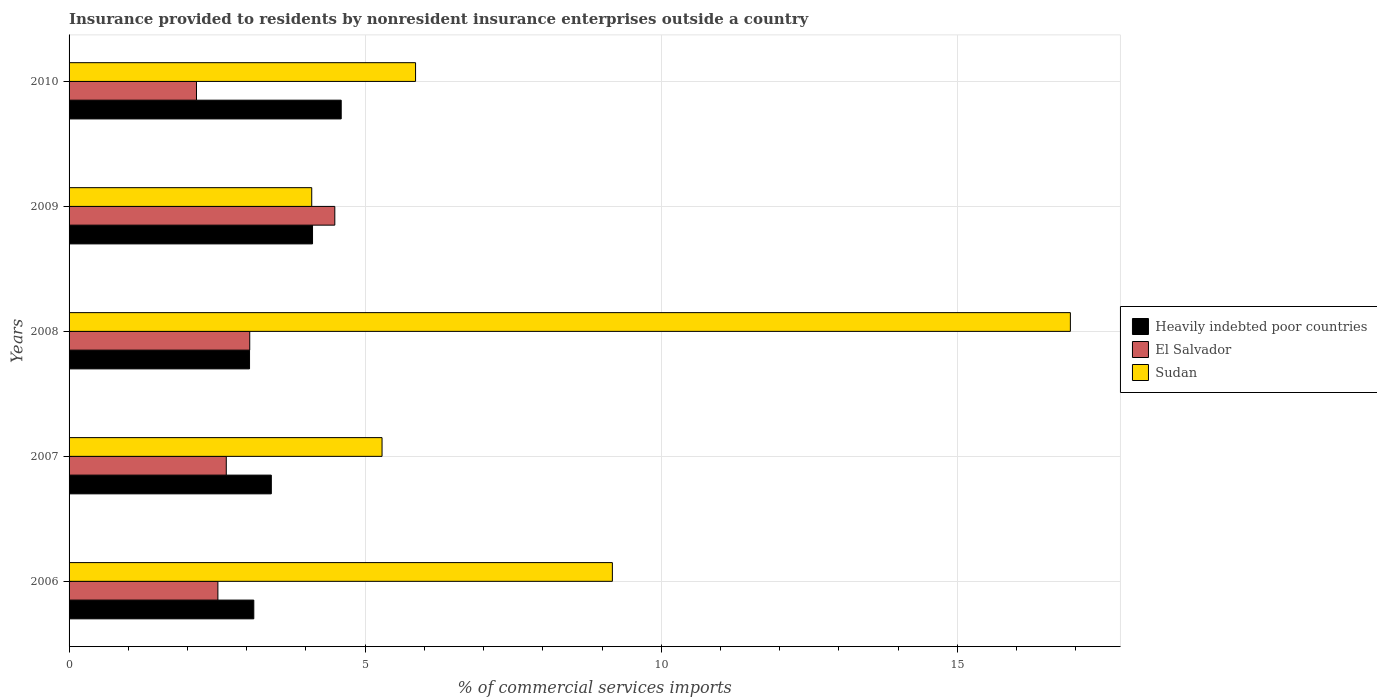Are the number of bars on each tick of the Y-axis equal?
Provide a short and direct response. Yes. How many bars are there on the 1st tick from the bottom?
Your response must be concise. 3. What is the Insurance provided to residents in Heavily indebted poor countries in 2006?
Keep it short and to the point. 3.12. Across all years, what is the maximum Insurance provided to residents in Sudan?
Offer a terse response. 16.91. Across all years, what is the minimum Insurance provided to residents in Heavily indebted poor countries?
Make the answer very short. 3.05. In which year was the Insurance provided to residents in El Salvador minimum?
Your answer should be very brief. 2010. What is the total Insurance provided to residents in Sudan in the graph?
Your answer should be compact. 41.32. What is the difference between the Insurance provided to residents in El Salvador in 2006 and that in 2010?
Give a very brief answer. 0.36. What is the difference between the Insurance provided to residents in Heavily indebted poor countries in 2010 and the Insurance provided to residents in Sudan in 2008?
Keep it short and to the point. -12.31. What is the average Insurance provided to residents in El Salvador per year?
Offer a terse response. 2.97. In the year 2006, what is the difference between the Insurance provided to residents in Heavily indebted poor countries and Insurance provided to residents in El Salvador?
Provide a short and direct response. 0.61. What is the ratio of the Insurance provided to residents in Heavily indebted poor countries in 2009 to that in 2010?
Make the answer very short. 0.89. Is the Insurance provided to residents in Heavily indebted poor countries in 2006 less than that in 2009?
Ensure brevity in your answer.  Yes. What is the difference between the highest and the second highest Insurance provided to residents in El Salvador?
Offer a terse response. 1.44. What is the difference between the highest and the lowest Insurance provided to residents in El Salvador?
Offer a terse response. 2.34. What does the 2nd bar from the top in 2010 represents?
Offer a very short reply. El Salvador. What does the 1st bar from the bottom in 2008 represents?
Make the answer very short. Heavily indebted poor countries. Are all the bars in the graph horizontal?
Keep it short and to the point. Yes. What is the difference between two consecutive major ticks on the X-axis?
Your answer should be very brief. 5. Does the graph contain grids?
Provide a short and direct response. Yes. Where does the legend appear in the graph?
Give a very brief answer. Center right. What is the title of the graph?
Offer a terse response. Insurance provided to residents by nonresident insurance enterprises outside a country. Does "Iran" appear as one of the legend labels in the graph?
Ensure brevity in your answer.  No. What is the label or title of the X-axis?
Your answer should be very brief. % of commercial services imports. What is the label or title of the Y-axis?
Keep it short and to the point. Years. What is the % of commercial services imports of Heavily indebted poor countries in 2006?
Provide a succinct answer. 3.12. What is the % of commercial services imports of El Salvador in 2006?
Your answer should be very brief. 2.51. What is the % of commercial services imports of Sudan in 2006?
Your response must be concise. 9.17. What is the % of commercial services imports of Heavily indebted poor countries in 2007?
Make the answer very short. 3.42. What is the % of commercial services imports in El Salvador in 2007?
Keep it short and to the point. 2.65. What is the % of commercial services imports of Sudan in 2007?
Provide a succinct answer. 5.29. What is the % of commercial services imports in Heavily indebted poor countries in 2008?
Your answer should be compact. 3.05. What is the % of commercial services imports of El Salvador in 2008?
Keep it short and to the point. 3.05. What is the % of commercial services imports in Sudan in 2008?
Provide a succinct answer. 16.91. What is the % of commercial services imports of Heavily indebted poor countries in 2009?
Keep it short and to the point. 4.11. What is the % of commercial services imports in El Salvador in 2009?
Offer a very short reply. 4.49. What is the % of commercial services imports of Sudan in 2009?
Offer a very short reply. 4.1. What is the % of commercial services imports of Heavily indebted poor countries in 2010?
Offer a terse response. 4.6. What is the % of commercial services imports of El Salvador in 2010?
Give a very brief answer. 2.15. What is the % of commercial services imports of Sudan in 2010?
Provide a succinct answer. 5.85. Across all years, what is the maximum % of commercial services imports of Heavily indebted poor countries?
Give a very brief answer. 4.6. Across all years, what is the maximum % of commercial services imports in El Salvador?
Provide a succinct answer. 4.49. Across all years, what is the maximum % of commercial services imports in Sudan?
Make the answer very short. 16.91. Across all years, what is the minimum % of commercial services imports of Heavily indebted poor countries?
Your answer should be compact. 3.05. Across all years, what is the minimum % of commercial services imports of El Salvador?
Your answer should be compact. 2.15. Across all years, what is the minimum % of commercial services imports in Sudan?
Ensure brevity in your answer.  4.1. What is the total % of commercial services imports in Heavily indebted poor countries in the graph?
Offer a terse response. 18.29. What is the total % of commercial services imports of El Salvador in the graph?
Provide a succinct answer. 14.86. What is the total % of commercial services imports of Sudan in the graph?
Give a very brief answer. 41.32. What is the difference between the % of commercial services imports in Heavily indebted poor countries in 2006 and that in 2007?
Provide a succinct answer. -0.3. What is the difference between the % of commercial services imports of El Salvador in 2006 and that in 2007?
Your response must be concise. -0.14. What is the difference between the % of commercial services imports in Sudan in 2006 and that in 2007?
Provide a succinct answer. 3.89. What is the difference between the % of commercial services imports of Heavily indebted poor countries in 2006 and that in 2008?
Your response must be concise. 0.07. What is the difference between the % of commercial services imports in El Salvador in 2006 and that in 2008?
Your answer should be compact. -0.54. What is the difference between the % of commercial services imports in Sudan in 2006 and that in 2008?
Give a very brief answer. -7.73. What is the difference between the % of commercial services imports of Heavily indebted poor countries in 2006 and that in 2009?
Ensure brevity in your answer.  -0.99. What is the difference between the % of commercial services imports in El Salvador in 2006 and that in 2009?
Ensure brevity in your answer.  -1.97. What is the difference between the % of commercial services imports in Sudan in 2006 and that in 2009?
Your answer should be compact. 5.08. What is the difference between the % of commercial services imports of Heavily indebted poor countries in 2006 and that in 2010?
Your answer should be compact. -1.48. What is the difference between the % of commercial services imports of El Salvador in 2006 and that in 2010?
Provide a succinct answer. 0.36. What is the difference between the % of commercial services imports in Sudan in 2006 and that in 2010?
Your answer should be very brief. 3.32. What is the difference between the % of commercial services imports in Heavily indebted poor countries in 2007 and that in 2008?
Give a very brief answer. 0.37. What is the difference between the % of commercial services imports in El Salvador in 2007 and that in 2008?
Ensure brevity in your answer.  -0.4. What is the difference between the % of commercial services imports of Sudan in 2007 and that in 2008?
Offer a very short reply. -11.62. What is the difference between the % of commercial services imports of Heavily indebted poor countries in 2007 and that in 2009?
Your answer should be very brief. -0.7. What is the difference between the % of commercial services imports of El Salvador in 2007 and that in 2009?
Provide a succinct answer. -1.83. What is the difference between the % of commercial services imports of Sudan in 2007 and that in 2009?
Give a very brief answer. 1.19. What is the difference between the % of commercial services imports in Heavily indebted poor countries in 2007 and that in 2010?
Offer a terse response. -1.18. What is the difference between the % of commercial services imports of El Salvador in 2007 and that in 2010?
Give a very brief answer. 0.5. What is the difference between the % of commercial services imports in Sudan in 2007 and that in 2010?
Give a very brief answer. -0.57. What is the difference between the % of commercial services imports in Heavily indebted poor countries in 2008 and that in 2009?
Your response must be concise. -1.06. What is the difference between the % of commercial services imports in El Salvador in 2008 and that in 2009?
Offer a very short reply. -1.44. What is the difference between the % of commercial services imports in Sudan in 2008 and that in 2009?
Provide a succinct answer. 12.81. What is the difference between the % of commercial services imports in Heavily indebted poor countries in 2008 and that in 2010?
Your answer should be very brief. -1.55. What is the difference between the % of commercial services imports of El Salvador in 2008 and that in 2010?
Keep it short and to the point. 0.9. What is the difference between the % of commercial services imports in Sudan in 2008 and that in 2010?
Your answer should be compact. 11.06. What is the difference between the % of commercial services imports of Heavily indebted poor countries in 2009 and that in 2010?
Make the answer very short. -0.48. What is the difference between the % of commercial services imports of El Salvador in 2009 and that in 2010?
Your response must be concise. 2.34. What is the difference between the % of commercial services imports of Sudan in 2009 and that in 2010?
Offer a very short reply. -1.75. What is the difference between the % of commercial services imports in Heavily indebted poor countries in 2006 and the % of commercial services imports in El Salvador in 2007?
Provide a short and direct response. 0.46. What is the difference between the % of commercial services imports in Heavily indebted poor countries in 2006 and the % of commercial services imports in Sudan in 2007?
Keep it short and to the point. -2.17. What is the difference between the % of commercial services imports in El Salvador in 2006 and the % of commercial services imports in Sudan in 2007?
Your answer should be compact. -2.77. What is the difference between the % of commercial services imports of Heavily indebted poor countries in 2006 and the % of commercial services imports of El Salvador in 2008?
Provide a short and direct response. 0.07. What is the difference between the % of commercial services imports of Heavily indebted poor countries in 2006 and the % of commercial services imports of Sudan in 2008?
Your answer should be compact. -13.79. What is the difference between the % of commercial services imports of El Salvador in 2006 and the % of commercial services imports of Sudan in 2008?
Provide a short and direct response. -14.4. What is the difference between the % of commercial services imports of Heavily indebted poor countries in 2006 and the % of commercial services imports of El Salvador in 2009?
Your answer should be very brief. -1.37. What is the difference between the % of commercial services imports of Heavily indebted poor countries in 2006 and the % of commercial services imports of Sudan in 2009?
Make the answer very short. -0.98. What is the difference between the % of commercial services imports in El Salvador in 2006 and the % of commercial services imports in Sudan in 2009?
Give a very brief answer. -1.58. What is the difference between the % of commercial services imports in Heavily indebted poor countries in 2006 and the % of commercial services imports in El Salvador in 2010?
Provide a succinct answer. 0.97. What is the difference between the % of commercial services imports in Heavily indebted poor countries in 2006 and the % of commercial services imports in Sudan in 2010?
Offer a very short reply. -2.73. What is the difference between the % of commercial services imports in El Salvador in 2006 and the % of commercial services imports in Sudan in 2010?
Make the answer very short. -3.34. What is the difference between the % of commercial services imports of Heavily indebted poor countries in 2007 and the % of commercial services imports of El Salvador in 2008?
Offer a very short reply. 0.36. What is the difference between the % of commercial services imports of Heavily indebted poor countries in 2007 and the % of commercial services imports of Sudan in 2008?
Ensure brevity in your answer.  -13.49. What is the difference between the % of commercial services imports of El Salvador in 2007 and the % of commercial services imports of Sudan in 2008?
Your answer should be very brief. -14.25. What is the difference between the % of commercial services imports in Heavily indebted poor countries in 2007 and the % of commercial services imports in El Salvador in 2009?
Offer a very short reply. -1.07. What is the difference between the % of commercial services imports of Heavily indebted poor countries in 2007 and the % of commercial services imports of Sudan in 2009?
Keep it short and to the point. -0.68. What is the difference between the % of commercial services imports of El Salvador in 2007 and the % of commercial services imports of Sudan in 2009?
Offer a terse response. -1.44. What is the difference between the % of commercial services imports in Heavily indebted poor countries in 2007 and the % of commercial services imports in El Salvador in 2010?
Offer a very short reply. 1.26. What is the difference between the % of commercial services imports in Heavily indebted poor countries in 2007 and the % of commercial services imports in Sudan in 2010?
Provide a succinct answer. -2.44. What is the difference between the % of commercial services imports in El Salvador in 2007 and the % of commercial services imports in Sudan in 2010?
Keep it short and to the point. -3.2. What is the difference between the % of commercial services imports of Heavily indebted poor countries in 2008 and the % of commercial services imports of El Salvador in 2009?
Offer a very short reply. -1.44. What is the difference between the % of commercial services imports of Heavily indebted poor countries in 2008 and the % of commercial services imports of Sudan in 2009?
Your answer should be compact. -1.05. What is the difference between the % of commercial services imports of El Salvador in 2008 and the % of commercial services imports of Sudan in 2009?
Offer a terse response. -1.05. What is the difference between the % of commercial services imports of Heavily indebted poor countries in 2008 and the % of commercial services imports of El Salvador in 2010?
Keep it short and to the point. 0.9. What is the difference between the % of commercial services imports of Heavily indebted poor countries in 2008 and the % of commercial services imports of Sudan in 2010?
Offer a terse response. -2.8. What is the difference between the % of commercial services imports in El Salvador in 2008 and the % of commercial services imports in Sudan in 2010?
Ensure brevity in your answer.  -2.8. What is the difference between the % of commercial services imports of Heavily indebted poor countries in 2009 and the % of commercial services imports of El Salvador in 2010?
Offer a very short reply. 1.96. What is the difference between the % of commercial services imports in Heavily indebted poor countries in 2009 and the % of commercial services imports in Sudan in 2010?
Give a very brief answer. -1.74. What is the difference between the % of commercial services imports in El Salvador in 2009 and the % of commercial services imports in Sudan in 2010?
Provide a short and direct response. -1.36. What is the average % of commercial services imports in Heavily indebted poor countries per year?
Provide a succinct answer. 3.66. What is the average % of commercial services imports in El Salvador per year?
Make the answer very short. 2.97. What is the average % of commercial services imports of Sudan per year?
Ensure brevity in your answer.  8.26. In the year 2006, what is the difference between the % of commercial services imports of Heavily indebted poor countries and % of commercial services imports of El Salvador?
Your response must be concise. 0.61. In the year 2006, what is the difference between the % of commercial services imports of Heavily indebted poor countries and % of commercial services imports of Sudan?
Your response must be concise. -6.06. In the year 2006, what is the difference between the % of commercial services imports of El Salvador and % of commercial services imports of Sudan?
Your answer should be compact. -6.66. In the year 2007, what is the difference between the % of commercial services imports of Heavily indebted poor countries and % of commercial services imports of El Salvador?
Give a very brief answer. 0.76. In the year 2007, what is the difference between the % of commercial services imports of Heavily indebted poor countries and % of commercial services imports of Sudan?
Give a very brief answer. -1.87. In the year 2007, what is the difference between the % of commercial services imports in El Salvador and % of commercial services imports in Sudan?
Your answer should be compact. -2.63. In the year 2008, what is the difference between the % of commercial services imports of Heavily indebted poor countries and % of commercial services imports of El Salvador?
Your response must be concise. -0. In the year 2008, what is the difference between the % of commercial services imports of Heavily indebted poor countries and % of commercial services imports of Sudan?
Your answer should be compact. -13.86. In the year 2008, what is the difference between the % of commercial services imports of El Salvador and % of commercial services imports of Sudan?
Your response must be concise. -13.86. In the year 2009, what is the difference between the % of commercial services imports of Heavily indebted poor countries and % of commercial services imports of El Salvador?
Make the answer very short. -0.38. In the year 2009, what is the difference between the % of commercial services imports in Heavily indebted poor countries and % of commercial services imports in Sudan?
Offer a very short reply. 0.01. In the year 2009, what is the difference between the % of commercial services imports of El Salvador and % of commercial services imports of Sudan?
Provide a short and direct response. 0.39. In the year 2010, what is the difference between the % of commercial services imports of Heavily indebted poor countries and % of commercial services imports of El Salvador?
Make the answer very short. 2.44. In the year 2010, what is the difference between the % of commercial services imports of Heavily indebted poor countries and % of commercial services imports of Sudan?
Your answer should be very brief. -1.26. In the year 2010, what is the difference between the % of commercial services imports in El Salvador and % of commercial services imports in Sudan?
Your answer should be very brief. -3.7. What is the ratio of the % of commercial services imports of Heavily indebted poor countries in 2006 to that in 2007?
Provide a short and direct response. 0.91. What is the ratio of the % of commercial services imports in El Salvador in 2006 to that in 2007?
Make the answer very short. 0.95. What is the ratio of the % of commercial services imports of Sudan in 2006 to that in 2007?
Provide a succinct answer. 1.74. What is the ratio of the % of commercial services imports of Heavily indebted poor countries in 2006 to that in 2008?
Your response must be concise. 1.02. What is the ratio of the % of commercial services imports of El Salvador in 2006 to that in 2008?
Offer a terse response. 0.82. What is the ratio of the % of commercial services imports in Sudan in 2006 to that in 2008?
Ensure brevity in your answer.  0.54. What is the ratio of the % of commercial services imports in Heavily indebted poor countries in 2006 to that in 2009?
Your response must be concise. 0.76. What is the ratio of the % of commercial services imports in El Salvador in 2006 to that in 2009?
Keep it short and to the point. 0.56. What is the ratio of the % of commercial services imports of Sudan in 2006 to that in 2009?
Your response must be concise. 2.24. What is the ratio of the % of commercial services imports of Heavily indebted poor countries in 2006 to that in 2010?
Give a very brief answer. 0.68. What is the ratio of the % of commercial services imports of El Salvador in 2006 to that in 2010?
Make the answer very short. 1.17. What is the ratio of the % of commercial services imports of Sudan in 2006 to that in 2010?
Your answer should be very brief. 1.57. What is the ratio of the % of commercial services imports of Heavily indebted poor countries in 2007 to that in 2008?
Ensure brevity in your answer.  1.12. What is the ratio of the % of commercial services imports in El Salvador in 2007 to that in 2008?
Ensure brevity in your answer.  0.87. What is the ratio of the % of commercial services imports in Sudan in 2007 to that in 2008?
Give a very brief answer. 0.31. What is the ratio of the % of commercial services imports in Heavily indebted poor countries in 2007 to that in 2009?
Provide a succinct answer. 0.83. What is the ratio of the % of commercial services imports in El Salvador in 2007 to that in 2009?
Offer a terse response. 0.59. What is the ratio of the % of commercial services imports of Sudan in 2007 to that in 2009?
Provide a short and direct response. 1.29. What is the ratio of the % of commercial services imports of Heavily indebted poor countries in 2007 to that in 2010?
Provide a succinct answer. 0.74. What is the ratio of the % of commercial services imports of El Salvador in 2007 to that in 2010?
Keep it short and to the point. 1.23. What is the ratio of the % of commercial services imports of Sudan in 2007 to that in 2010?
Give a very brief answer. 0.9. What is the ratio of the % of commercial services imports of Heavily indebted poor countries in 2008 to that in 2009?
Ensure brevity in your answer.  0.74. What is the ratio of the % of commercial services imports in El Salvador in 2008 to that in 2009?
Offer a very short reply. 0.68. What is the ratio of the % of commercial services imports in Sudan in 2008 to that in 2009?
Provide a short and direct response. 4.13. What is the ratio of the % of commercial services imports of Heavily indebted poor countries in 2008 to that in 2010?
Keep it short and to the point. 0.66. What is the ratio of the % of commercial services imports in El Salvador in 2008 to that in 2010?
Offer a terse response. 1.42. What is the ratio of the % of commercial services imports of Sudan in 2008 to that in 2010?
Provide a short and direct response. 2.89. What is the ratio of the % of commercial services imports in Heavily indebted poor countries in 2009 to that in 2010?
Offer a very short reply. 0.89. What is the ratio of the % of commercial services imports in El Salvador in 2009 to that in 2010?
Your response must be concise. 2.09. What is the ratio of the % of commercial services imports of Sudan in 2009 to that in 2010?
Provide a succinct answer. 0.7. What is the difference between the highest and the second highest % of commercial services imports of Heavily indebted poor countries?
Offer a very short reply. 0.48. What is the difference between the highest and the second highest % of commercial services imports in El Salvador?
Provide a short and direct response. 1.44. What is the difference between the highest and the second highest % of commercial services imports of Sudan?
Make the answer very short. 7.73. What is the difference between the highest and the lowest % of commercial services imports of Heavily indebted poor countries?
Provide a succinct answer. 1.55. What is the difference between the highest and the lowest % of commercial services imports in El Salvador?
Keep it short and to the point. 2.34. What is the difference between the highest and the lowest % of commercial services imports of Sudan?
Your response must be concise. 12.81. 